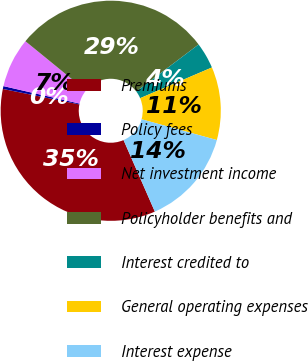Convert chart to OTSL. <chart><loc_0><loc_0><loc_500><loc_500><pie_chart><fcel>Premiums<fcel>Policy fees<fcel>Net investment income<fcel>Policyholder benefits and<fcel>Interest credited to<fcel>General operating expenses<fcel>Interest expense<nl><fcel>34.74%<fcel>0.42%<fcel>7.29%<fcel>28.83%<fcel>3.85%<fcel>10.72%<fcel>14.15%<nl></chart> 